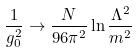<formula> <loc_0><loc_0><loc_500><loc_500>\frac { 1 } { g _ { 0 } ^ { 2 } } \rightarrow \frac { N } { 9 6 \pi ^ { 2 } } \ln \frac { \Lambda ^ { 2 } } { m ^ { 2 } }</formula> 